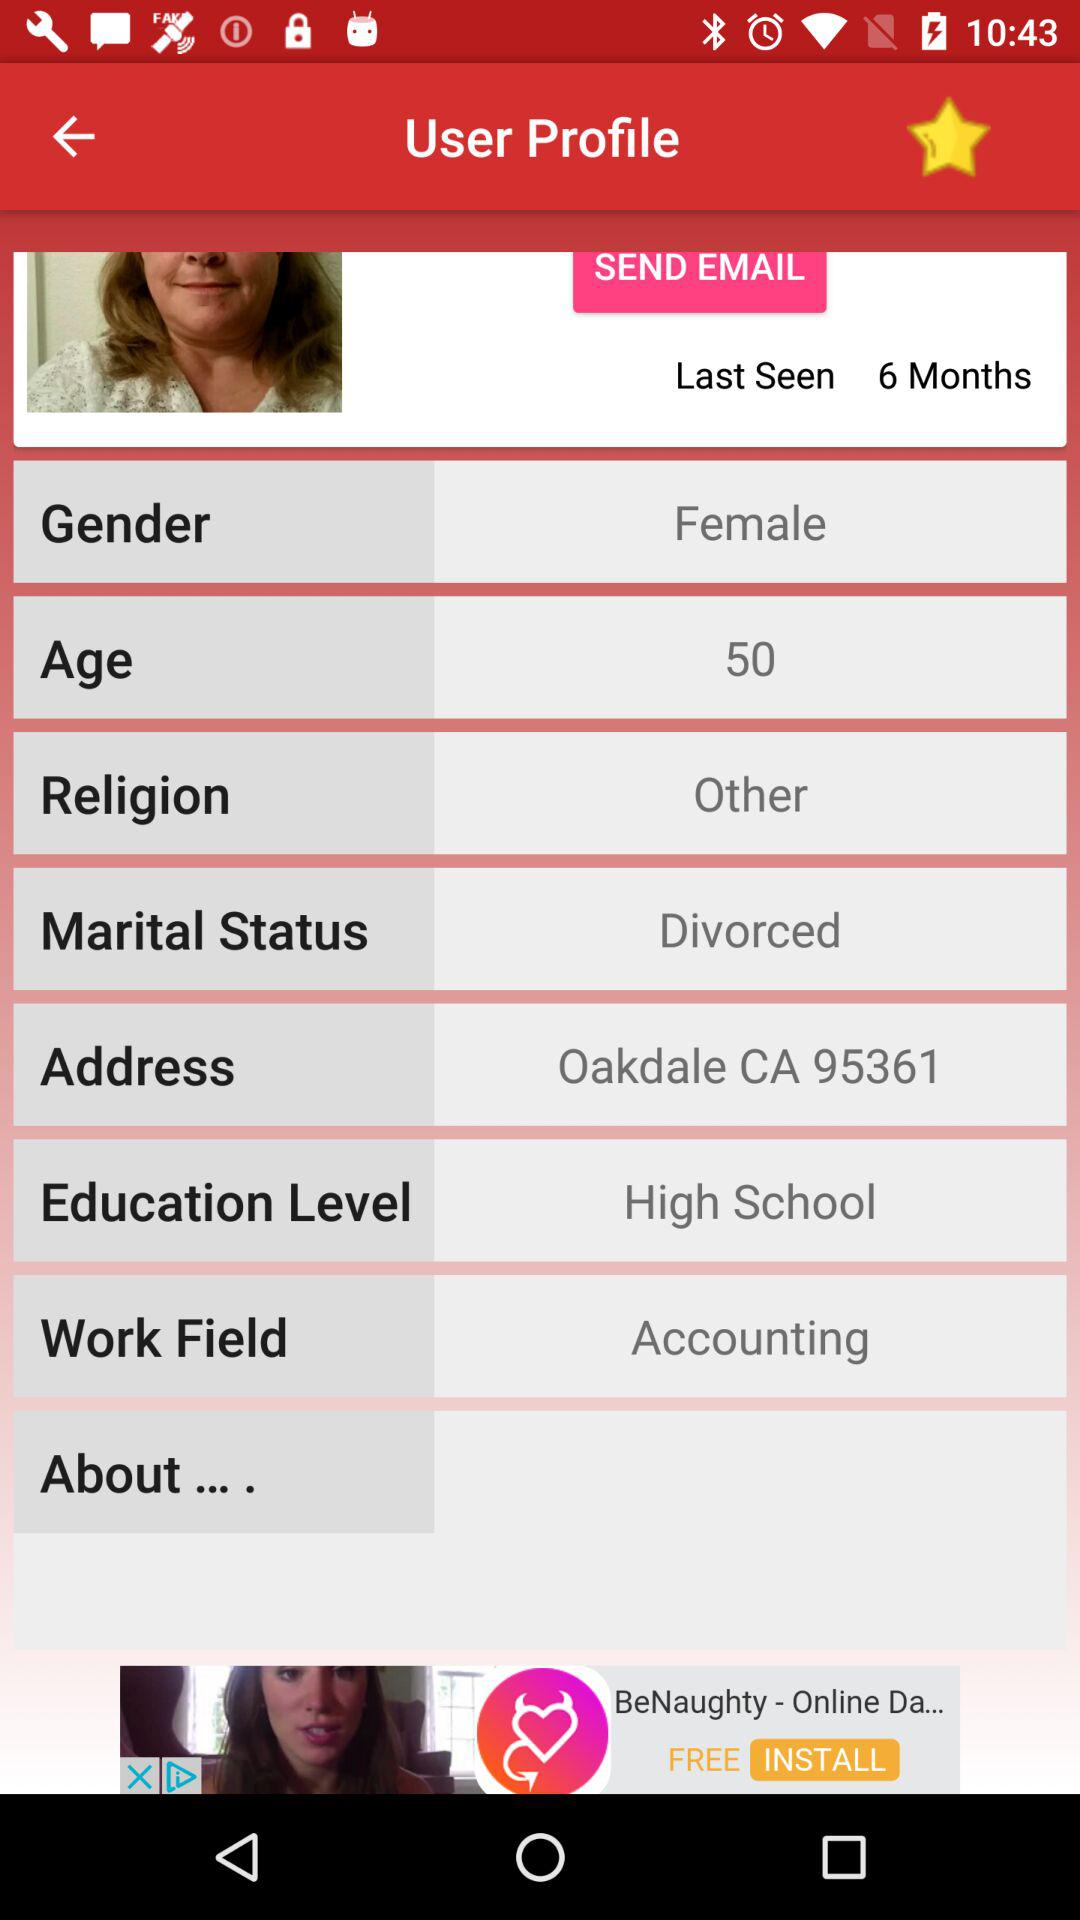What is the qualification level? The qualification level is high school. 